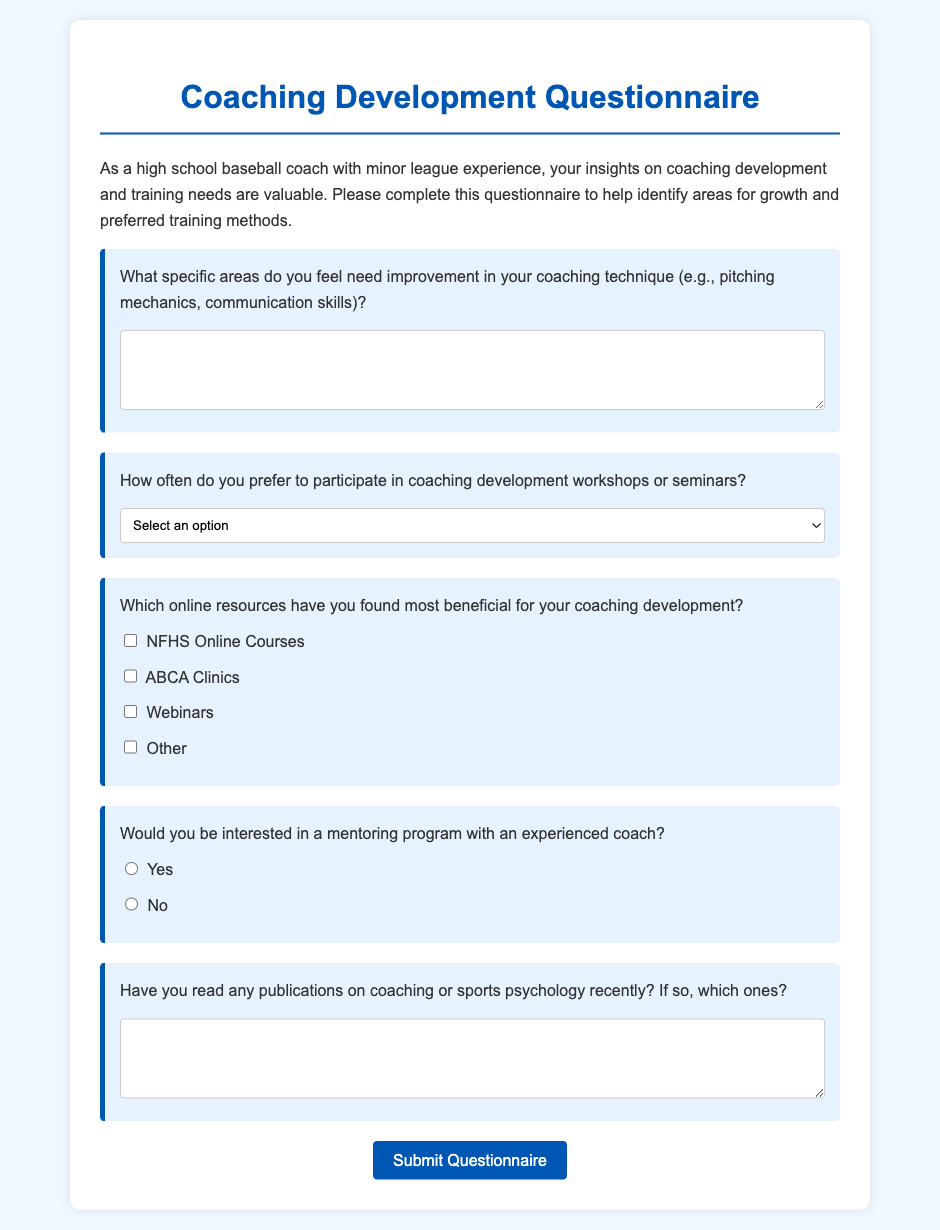What is the title of the document? The title is found at the top of the document, which introduces the content.
Answer: Coaching Development Questionnaire What is the main focus of this questionnaire? The main purpose of the questionnaire is outlined in the introductory paragraph.
Answer: Coaching development and training needs How often can respondents select to participate in workshops? This information is listed as options within a dropdown selection in the questionnaire.
Answer: Monthly, Quarterly, Bi-annually, Annually What specific area can coaches suggest for improvement? This detail is mentioned in the first question, asking about areas needing improvement.
Answer: Coaching technique What is the required format for answering the question about recent publications? The requirement is based on the type of response expected for that question in the document.
Answer: Short-answer text Are there opportunities for a mentoring program mentioned? This detail is found in one of the questions regarding further support for coaches.
Answer: Yes 